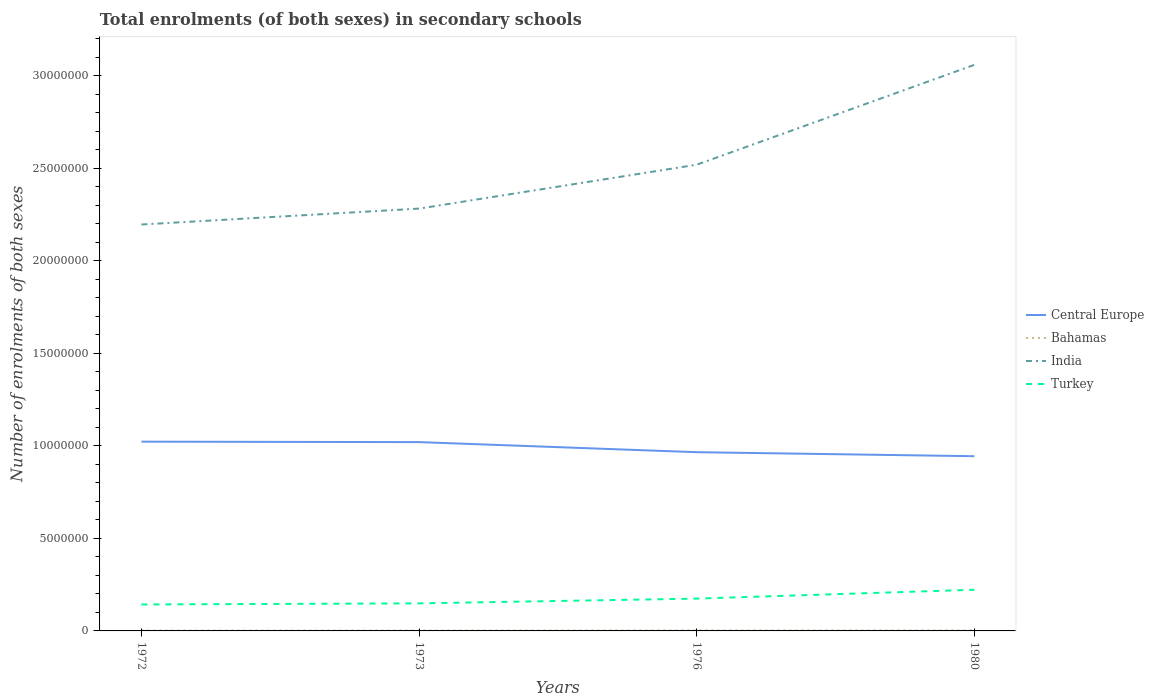Across all years, what is the maximum number of enrolments in secondary schools in India?
Keep it short and to the point. 2.20e+07. In which year was the number of enrolments in secondary schools in Bahamas maximum?
Your answer should be very brief. 1972. What is the total number of enrolments in secondary schools in India in the graph?
Ensure brevity in your answer.  -5.40e+06. What is the difference between the highest and the second highest number of enrolments in secondary schools in Turkey?
Your answer should be very brief. 7.96e+05. What is the difference between the highest and the lowest number of enrolments in secondary schools in Bahamas?
Give a very brief answer. 2. Is the number of enrolments in secondary schools in Turkey strictly greater than the number of enrolments in secondary schools in Bahamas over the years?
Offer a very short reply. No. How many years are there in the graph?
Offer a very short reply. 4. What is the difference between two consecutive major ticks on the Y-axis?
Your answer should be very brief. 5.00e+06. Does the graph contain any zero values?
Offer a very short reply. No. Does the graph contain grids?
Ensure brevity in your answer.  No. Where does the legend appear in the graph?
Make the answer very short. Center right. How many legend labels are there?
Your response must be concise. 4. How are the legend labels stacked?
Ensure brevity in your answer.  Vertical. What is the title of the graph?
Keep it short and to the point. Total enrolments (of both sexes) in secondary schools. What is the label or title of the X-axis?
Your answer should be very brief. Years. What is the label or title of the Y-axis?
Keep it short and to the point. Number of enrolments of both sexes. What is the Number of enrolments of both sexes of Central Europe in 1972?
Your response must be concise. 1.02e+07. What is the Number of enrolments of both sexes in Bahamas in 1972?
Give a very brief answer. 2.25e+04. What is the Number of enrolments of both sexes of India in 1972?
Offer a terse response. 2.20e+07. What is the Number of enrolments of both sexes in Turkey in 1972?
Your answer should be very brief. 1.43e+06. What is the Number of enrolments of both sexes in Central Europe in 1973?
Provide a succinct answer. 1.02e+07. What is the Number of enrolments of both sexes of Bahamas in 1973?
Make the answer very short. 2.33e+04. What is the Number of enrolments of both sexes of India in 1973?
Make the answer very short. 2.28e+07. What is the Number of enrolments of both sexes in Turkey in 1973?
Ensure brevity in your answer.  1.49e+06. What is the Number of enrolments of both sexes in Central Europe in 1976?
Your response must be concise. 9.66e+06. What is the Number of enrolments of both sexes of Bahamas in 1976?
Your answer should be very brief. 3.06e+04. What is the Number of enrolments of both sexes of India in 1976?
Keep it short and to the point. 2.52e+07. What is the Number of enrolments of both sexes of Turkey in 1976?
Ensure brevity in your answer.  1.75e+06. What is the Number of enrolments of both sexes in Central Europe in 1980?
Your answer should be compact. 9.44e+06. What is the Number of enrolments of both sexes of Bahamas in 1980?
Your answer should be compact. 3.02e+04. What is the Number of enrolments of both sexes of India in 1980?
Your answer should be very brief. 3.06e+07. What is the Number of enrolments of both sexes of Turkey in 1980?
Offer a terse response. 2.23e+06. Across all years, what is the maximum Number of enrolments of both sexes of Central Europe?
Provide a succinct answer. 1.02e+07. Across all years, what is the maximum Number of enrolments of both sexes in Bahamas?
Your answer should be compact. 3.06e+04. Across all years, what is the maximum Number of enrolments of both sexes in India?
Provide a short and direct response. 3.06e+07. Across all years, what is the maximum Number of enrolments of both sexes in Turkey?
Provide a short and direct response. 2.23e+06. Across all years, what is the minimum Number of enrolments of both sexes of Central Europe?
Make the answer very short. 9.44e+06. Across all years, what is the minimum Number of enrolments of both sexes in Bahamas?
Your answer should be compact. 2.25e+04. Across all years, what is the minimum Number of enrolments of both sexes in India?
Make the answer very short. 2.20e+07. Across all years, what is the minimum Number of enrolments of both sexes of Turkey?
Ensure brevity in your answer.  1.43e+06. What is the total Number of enrolments of both sexes in Central Europe in the graph?
Make the answer very short. 3.95e+07. What is the total Number of enrolments of both sexes of Bahamas in the graph?
Provide a short and direct response. 1.07e+05. What is the total Number of enrolments of both sexes in India in the graph?
Your answer should be very brief. 1.01e+08. What is the total Number of enrolments of both sexes in Turkey in the graph?
Make the answer very short. 6.89e+06. What is the difference between the Number of enrolments of both sexes of Central Europe in 1972 and that in 1973?
Ensure brevity in your answer.  2.41e+04. What is the difference between the Number of enrolments of both sexes in Bahamas in 1972 and that in 1973?
Give a very brief answer. -781. What is the difference between the Number of enrolments of both sexes in India in 1972 and that in 1973?
Offer a very short reply. -8.59e+05. What is the difference between the Number of enrolments of both sexes in Turkey in 1972 and that in 1973?
Provide a succinct answer. -6.01e+04. What is the difference between the Number of enrolments of both sexes in Central Europe in 1972 and that in 1976?
Provide a succinct answer. 5.69e+05. What is the difference between the Number of enrolments of both sexes in Bahamas in 1972 and that in 1976?
Provide a succinct answer. -8074. What is the difference between the Number of enrolments of both sexes in India in 1972 and that in 1976?
Your answer should be very brief. -3.23e+06. What is the difference between the Number of enrolments of both sexes in Turkey in 1972 and that in 1976?
Make the answer very short. -3.17e+05. What is the difference between the Number of enrolments of both sexes in Central Europe in 1972 and that in 1980?
Keep it short and to the point. 7.86e+05. What is the difference between the Number of enrolments of both sexes in Bahamas in 1972 and that in 1980?
Ensure brevity in your answer.  -7688. What is the difference between the Number of enrolments of both sexes in India in 1972 and that in 1980?
Make the answer very short. -8.63e+06. What is the difference between the Number of enrolments of both sexes in Turkey in 1972 and that in 1980?
Provide a short and direct response. -7.96e+05. What is the difference between the Number of enrolments of both sexes of Central Europe in 1973 and that in 1976?
Your answer should be very brief. 5.45e+05. What is the difference between the Number of enrolments of both sexes in Bahamas in 1973 and that in 1976?
Make the answer very short. -7293. What is the difference between the Number of enrolments of both sexes of India in 1973 and that in 1976?
Keep it short and to the point. -2.37e+06. What is the difference between the Number of enrolments of both sexes in Turkey in 1973 and that in 1976?
Ensure brevity in your answer.  -2.56e+05. What is the difference between the Number of enrolments of both sexes of Central Europe in 1973 and that in 1980?
Your answer should be very brief. 7.62e+05. What is the difference between the Number of enrolments of both sexes of Bahamas in 1973 and that in 1980?
Keep it short and to the point. -6907. What is the difference between the Number of enrolments of both sexes of India in 1973 and that in 1980?
Provide a short and direct response. -7.77e+06. What is the difference between the Number of enrolments of both sexes of Turkey in 1973 and that in 1980?
Ensure brevity in your answer.  -7.36e+05. What is the difference between the Number of enrolments of both sexes of Central Europe in 1976 and that in 1980?
Offer a terse response. 2.17e+05. What is the difference between the Number of enrolments of both sexes of Bahamas in 1976 and that in 1980?
Make the answer very short. 386. What is the difference between the Number of enrolments of both sexes in India in 1976 and that in 1980?
Provide a succinct answer. -5.40e+06. What is the difference between the Number of enrolments of both sexes of Turkey in 1976 and that in 1980?
Your answer should be very brief. -4.79e+05. What is the difference between the Number of enrolments of both sexes of Central Europe in 1972 and the Number of enrolments of both sexes of Bahamas in 1973?
Your answer should be compact. 1.02e+07. What is the difference between the Number of enrolments of both sexes of Central Europe in 1972 and the Number of enrolments of both sexes of India in 1973?
Your answer should be compact. -1.26e+07. What is the difference between the Number of enrolments of both sexes in Central Europe in 1972 and the Number of enrolments of both sexes in Turkey in 1973?
Keep it short and to the point. 8.74e+06. What is the difference between the Number of enrolments of both sexes of Bahamas in 1972 and the Number of enrolments of both sexes of India in 1973?
Keep it short and to the point. -2.28e+07. What is the difference between the Number of enrolments of both sexes of Bahamas in 1972 and the Number of enrolments of both sexes of Turkey in 1973?
Provide a short and direct response. -1.47e+06. What is the difference between the Number of enrolments of both sexes in India in 1972 and the Number of enrolments of both sexes in Turkey in 1973?
Provide a succinct answer. 2.05e+07. What is the difference between the Number of enrolments of both sexes in Central Europe in 1972 and the Number of enrolments of both sexes in Bahamas in 1976?
Your answer should be compact. 1.02e+07. What is the difference between the Number of enrolments of both sexes of Central Europe in 1972 and the Number of enrolments of both sexes of India in 1976?
Provide a succinct answer. -1.50e+07. What is the difference between the Number of enrolments of both sexes of Central Europe in 1972 and the Number of enrolments of both sexes of Turkey in 1976?
Your response must be concise. 8.48e+06. What is the difference between the Number of enrolments of both sexes of Bahamas in 1972 and the Number of enrolments of both sexes of India in 1976?
Provide a short and direct response. -2.52e+07. What is the difference between the Number of enrolments of both sexes of Bahamas in 1972 and the Number of enrolments of both sexes of Turkey in 1976?
Offer a terse response. -1.72e+06. What is the difference between the Number of enrolments of both sexes in India in 1972 and the Number of enrolments of both sexes in Turkey in 1976?
Provide a short and direct response. 2.02e+07. What is the difference between the Number of enrolments of both sexes of Central Europe in 1972 and the Number of enrolments of both sexes of Bahamas in 1980?
Offer a very short reply. 1.02e+07. What is the difference between the Number of enrolments of both sexes of Central Europe in 1972 and the Number of enrolments of both sexes of India in 1980?
Provide a short and direct response. -2.04e+07. What is the difference between the Number of enrolments of both sexes in Central Europe in 1972 and the Number of enrolments of both sexes in Turkey in 1980?
Keep it short and to the point. 8.00e+06. What is the difference between the Number of enrolments of both sexes of Bahamas in 1972 and the Number of enrolments of both sexes of India in 1980?
Provide a short and direct response. -3.06e+07. What is the difference between the Number of enrolments of both sexes in Bahamas in 1972 and the Number of enrolments of both sexes in Turkey in 1980?
Your answer should be compact. -2.20e+06. What is the difference between the Number of enrolments of both sexes of India in 1972 and the Number of enrolments of both sexes of Turkey in 1980?
Offer a terse response. 1.97e+07. What is the difference between the Number of enrolments of both sexes of Central Europe in 1973 and the Number of enrolments of both sexes of Bahamas in 1976?
Your answer should be very brief. 1.02e+07. What is the difference between the Number of enrolments of both sexes of Central Europe in 1973 and the Number of enrolments of both sexes of India in 1976?
Provide a succinct answer. -1.50e+07. What is the difference between the Number of enrolments of both sexes in Central Europe in 1973 and the Number of enrolments of both sexes in Turkey in 1976?
Provide a short and direct response. 8.46e+06. What is the difference between the Number of enrolments of both sexes of Bahamas in 1973 and the Number of enrolments of both sexes of India in 1976?
Give a very brief answer. -2.52e+07. What is the difference between the Number of enrolments of both sexes in Bahamas in 1973 and the Number of enrolments of both sexes in Turkey in 1976?
Provide a short and direct response. -1.72e+06. What is the difference between the Number of enrolments of both sexes in India in 1973 and the Number of enrolments of both sexes in Turkey in 1976?
Offer a terse response. 2.11e+07. What is the difference between the Number of enrolments of both sexes of Central Europe in 1973 and the Number of enrolments of both sexes of Bahamas in 1980?
Your answer should be compact. 1.02e+07. What is the difference between the Number of enrolments of both sexes in Central Europe in 1973 and the Number of enrolments of both sexes in India in 1980?
Provide a succinct answer. -2.04e+07. What is the difference between the Number of enrolments of both sexes of Central Europe in 1973 and the Number of enrolments of both sexes of Turkey in 1980?
Offer a very short reply. 7.98e+06. What is the difference between the Number of enrolments of both sexes in Bahamas in 1973 and the Number of enrolments of both sexes in India in 1980?
Your answer should be compact. -3.06e+07. What is the difference between the Number of enrolments of both sexes in Bahamas in 1973 and the Number of enrolments of both sexes in Turkey in 1980?
Keep it short and to the point. -2.20e+06. What is the difference between the Number of enrolments of both sexes in India in 1973 and the Number of enrolments of both sexes in Turkey in 1980?
Provide a succinct answer. 2.06e+07. What is the difference between the Number of enrolments of both sexes of Central Europe in 1976 and the Number of enrolments of both sexes of Bahamas in 1980?
Your answer should be very brief. 9.63e+06. What is the difference between the Number of enrolments of both sexes in Central Europe in 1976 and the Number of enrolments of both sexes in India in 1980?
Your answer should be very brief. -2.09e+07. What is the difference between the Number of enrolments of both sexes in Central Europe in 1976 and the Number of enrolments of both sexes in Turkey in 1980?
Give a very brief answer. 7.43e+06. What is the difference between the Number of enrolments of both sexes in Bahamas in 1976 and the Number of enrolments of both sexes in India in 1980?
Your response must be concise. -3.06e+07. What is the difference between the Number of enrolments of both sexes in Bahamas in 1976 and the Number of enrolments of both sexes in Turkey in 1980?
Offer a terse response. -2.19e+06. What is the difference between the Number of enrolments of both sexes of India in 1976 and the Number of enrolments of both sexes of Turkey in 1980?
Give a very brief answer. 2.30e+07. What is the average Number of enrolments of both sexes in Central Europe per year?
Offer a terse response. 9.88e+06. What is the average Number of enrolments of both sexes in Bahamas per year?
Offer a terse response. 2.67e+04. What is the average Number of enrolments of both sexes in India per year?
Keep it short and to the point. 2.51e+07. What is the average Number of enrolments of both sexes in Turkey per year?
Your answer should be very brief. 1.72e+06. In the year 1972, what is the difference between the Number of enrolments of both sexes in Central Europe and Number of enrolments of both sexes in Bahamas?
Offer a terse response. 1.02e+07. In the year 1972, what is the difference between the Number of enrolments of both sexes in Central Europe and Number of enrolments of both sexes in India?
Offer a very short reply. -1.17e+07. In the year 1972, what is the difference between the Number of enrolments of both sexes of Central Europe and Number of enrolments of both sexes of Turkey?
Your response must be concise. 8.80e+06. In the year 1972, what is the difference between the Number of enrolments of both sexes in Bahamas and Number of enrolments of both sexes in India?
Ensure brevity in your answer.  -2.19e+07. In the year 1972, what is the difference between the Number of enrolments of both sexes in Bahamas and Number of enrolments of both sexes in Turkey?
Your answer should be compact. -1.41e+06. In the year 1972, what is the difference between the Number of enrolments of both sexes of India and Number of enrolments of both sexes of Turkey?
Offer a very short reply. 2.05e+07. In the year 1973, what is the difference between the Number of enrolments of both sexes of Central Europe and Number of enrolments of both sexes of Bahamas?
Your answer should be very brief. 1.02e+07. In the year 1973, what is the difference between the Number of enrolments of both sexes of Central Europe and Number of enrolments of both sexes of India?
Keep it short and to the point. -1.26e+07. In the year 1973, what is the difference between the Number of enrolments of both sexes in Central Europe and Number of enrolments of both sexes in Turkey?
Your answer should be compact. 8.71e+06. In the year 1973, what is the difference between the Number of enrolments of both sexes in Bahamas and Number of enrolments of both sexes in India?
Make the answer very short. -2.28e+07. In the year 1973, what is the difference between the Number of enrolments of both sexes in Bahamas and Number of enrolments of both sexes in Turkey?
Offer a very short reply. -1.47e+06. In the year 1973, what is the difference between the Number of enrolments of both sexes in India and Number of enrolments of both sexes in Turkey?
Give a very brief answer. 2.13e+07. In the year 1976, what is the difference between the Number of enrolments of both sexes of Central Europe and Number of enrolments of both sexes of Bahamas?
Ensure brevity in your answer.  9.63e+06. In the year 1976, what is the difference between the Number of enrolments of both sexes of Central Europe and Number of enrolments of both sexes of India?
Provide a succinct answer. -1.55e+07. In the year 1976, what is the difference between the Number of enrolments of both sexes in Central Europe and Number of enrolments of both sexes in Turkey?
Offer a terse response. 7.91e+06. In the year 1976, what is the difference between the Number of enrolments of both sexes of Bahamas and Number of enrolments of both sexes of India?
Provide a short and direct response. -2.52e+07. In the year 1976, what is the difference between the Number of enrolments of both sexes in Bahamas and Number of enrolments of both sexes in Turkey?
Your response must be concise. -1.72e+06. In the year 1976, what is the difference between the Number of enrolments of both sexes of India and Number of enrolments of both sexes of Turkey?
Provide a succinct answer. 2.34e+07. In the year 1980, what is the difference between the Number of enrolments of both sexes in Central Europe and Number of enrolments of both sexes in Bahamas?
Your answer should be very brief. 9.41e+06. In the year 1980, what is the difference between the Number of enrolments of both sexes in Central Europe and Number of enrolments of both sexes in India?
Your answer should be very brief. -2.12e+07. In the year 1980, what is the difference between the Number of enrolments of both sexes of Central Europe and Number of enrolments of both sexes of Turkey?
Your answer should be very brief. 7.22e+06. In the year 1980, what is the difference between the Number of enrolments of both sexes in Bahamas and Number of enrolments of both sexes in India?
Ensure brevity in your answer.  -3.06e+07. In the year 1980, what is the difference between the Number of enrolments of both sexes in Bahamas and Number of enrolments of both sexes in Turkey?
Offer a terse response. -2.20e+06. In the year 1980, what is the difference between the Number of enrolments of both sexes in India and Number of enrolments of both sexes in Turkey?
Keep it short and to the point. 2.84e+07. What is the ratio of the Number of enrolments of both sexes of Central Europe in 1972 to that in 1973?
Provide a succinct answer. 1. What is the ratio of the Number of enrolments of both sexes in Bahamas in 1972 to that in 1973?
Ensure brevity in your answer.  0.97. What is the ratio of the Number of enrolments of both sexes in India in 1972 to that in 1973?
Your answer should be compact. 0.96. What is the ratio of the Number of enrolments of both sexes of Turkey in 1972 to that in 1973?
Ensure brevity in your answer.  0.96. What is the ratio of the Number of enrolments of both sexes in Central Europe in 1972 to that in 1976?
Your response must be concise. 1.06. What is the ratio of the Number of enrolments of both sexes in Bahamas in 1972 to that in 1976?
Ensure brevity in your answer.  0.74. What is the ratio of the Number of enrolments of both sexes of India in 1972 to that in 1976?
Provide a succinct answer. 0.87. What is the ratio of the Number of enrolments of both sexes of Turkey in 1972 to that in 1976?
Provide a succinct answer. 0.82. What is the ratio of the Number of enrolments of both sexes of Bahamas in 1972 to that in 1980?
Offer a terse response. 0.75. What is the ratio of the Number of enrolments of both sexes in India in 1972 to that in 1980?
Provide a succinct answer. 0.72. What is the ratio of the Number of enrolments of both sexes in Turkey in 1972 to that in 1980?
Make the answer very short. 0.64. What is the ratio of the Number of enrolments of both sexes of Central Europe in 1973 to that in 1976?
Your response must be concise. 1.06. What is the ratio of the Number of enrolments of both sexes of Bahamas in 1973 to that in 1976?
Ensure brevity in your answer.  0.76. What is the ratio of the Number of enrolments of both sexes of India in 1973 to that in 1976?
Your answer should be very brief. 0.91. What is the ratio of the Number of enrolments of both sexes in Turkey in 1973 to that in 1976?
Offer a very short reply. 0.85. What is the ratio of the Number of enrolments of both sexes in Central Europe in 1973 to that in 1980?
Make the answer very short. 1.08. What is the ratio of the Number of enrolments of both sexes of Bahamas in 1973 to that in 1980?
Provide a succinct answer. 0.77. What is the ratio of the Number of enrolments of both sexes of India in 1973 to that in 1980?
Your answer should be very brief. 0.75. What is the ratio of the Number of enrolments of both sexes of Turkey in 1973 to that in 1980?
Ensure brevity in your answer.  0.67. What is the ratio of the Number of enrolments of both sexes of Bahamas in 1976 to that in 1980?
Keep it short and to the point. 1.01. What is the ratio of the Number of enrolments of both sexes of India in 1976 to that in 1980?
Provide a succinct answer. 0.82. What is the ratio of the Number of enrolments of both sexes of Turkey in 1976 to that in 1980?
Your response must be concise. 0.78. What is the difference between the highest and the second highest Number of enrolments of both sexes of Central Europe?
Your response must be concise. 2.41e+04. What is the difference between the highest and the second highest Number of enrolments of both sexes of Bahamas?
Offer a terse response. 386. What is the difference between the highest and the second highest Number of enrolments of both sexes of India?
Offer a very short reply. 5.40e+06. What is the difference between the highest and the second highest Number of enrolments of both sexes of Turkey?
Offer a very short reply. 4.79e+05. What is the difference between the highest and the lowest Number of enrolments of both sexes of Central Europe?
Your answer should be compact. 7.86e+05. What is the difference between the highest and the lowest Number of enrolments of both sexes of Bahamas?
Make the answer very short. 8074. What is the difference between the highest and the lowest Number of enrolments of both sexes in India?
Your answer should be compact. 8.63e+06. What is the difference between the highest and the lowest Number of enrolments of both sexes of Turkey?
Provide a short and direct response. 7.96e+05. 